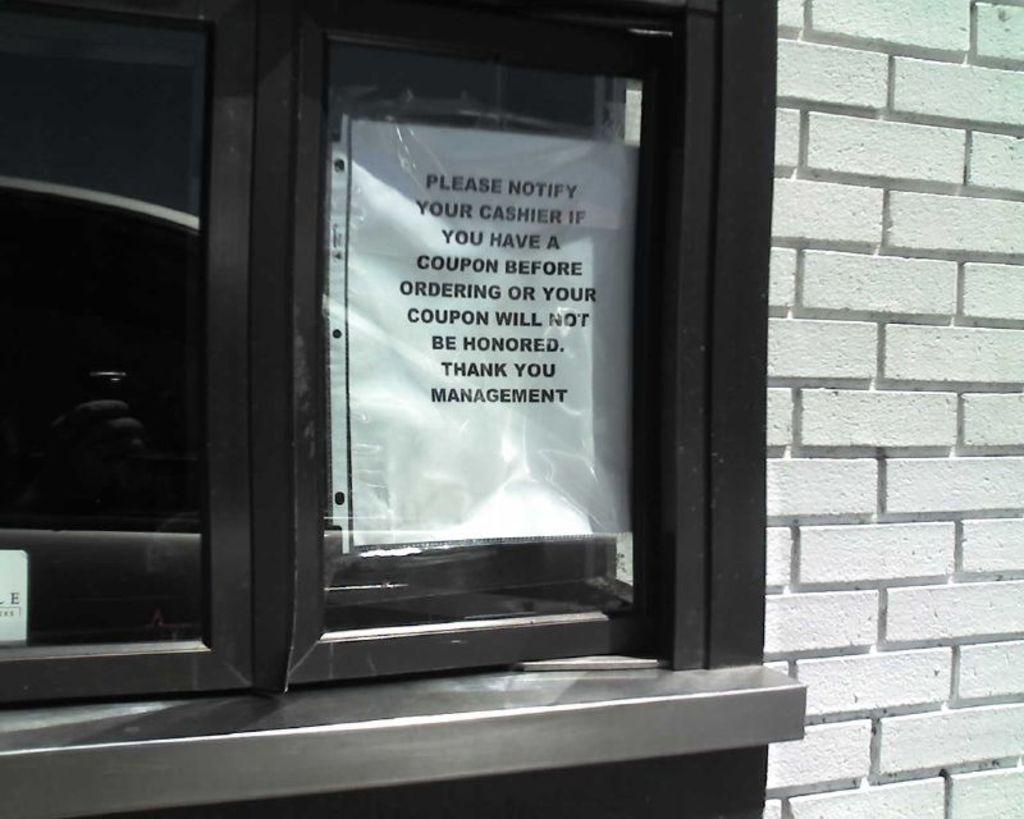<image>
Describe the image concisely. A drive thru window that has a sign up to notify cashier if you have a coupon or your coupon will not be honored written by management. 